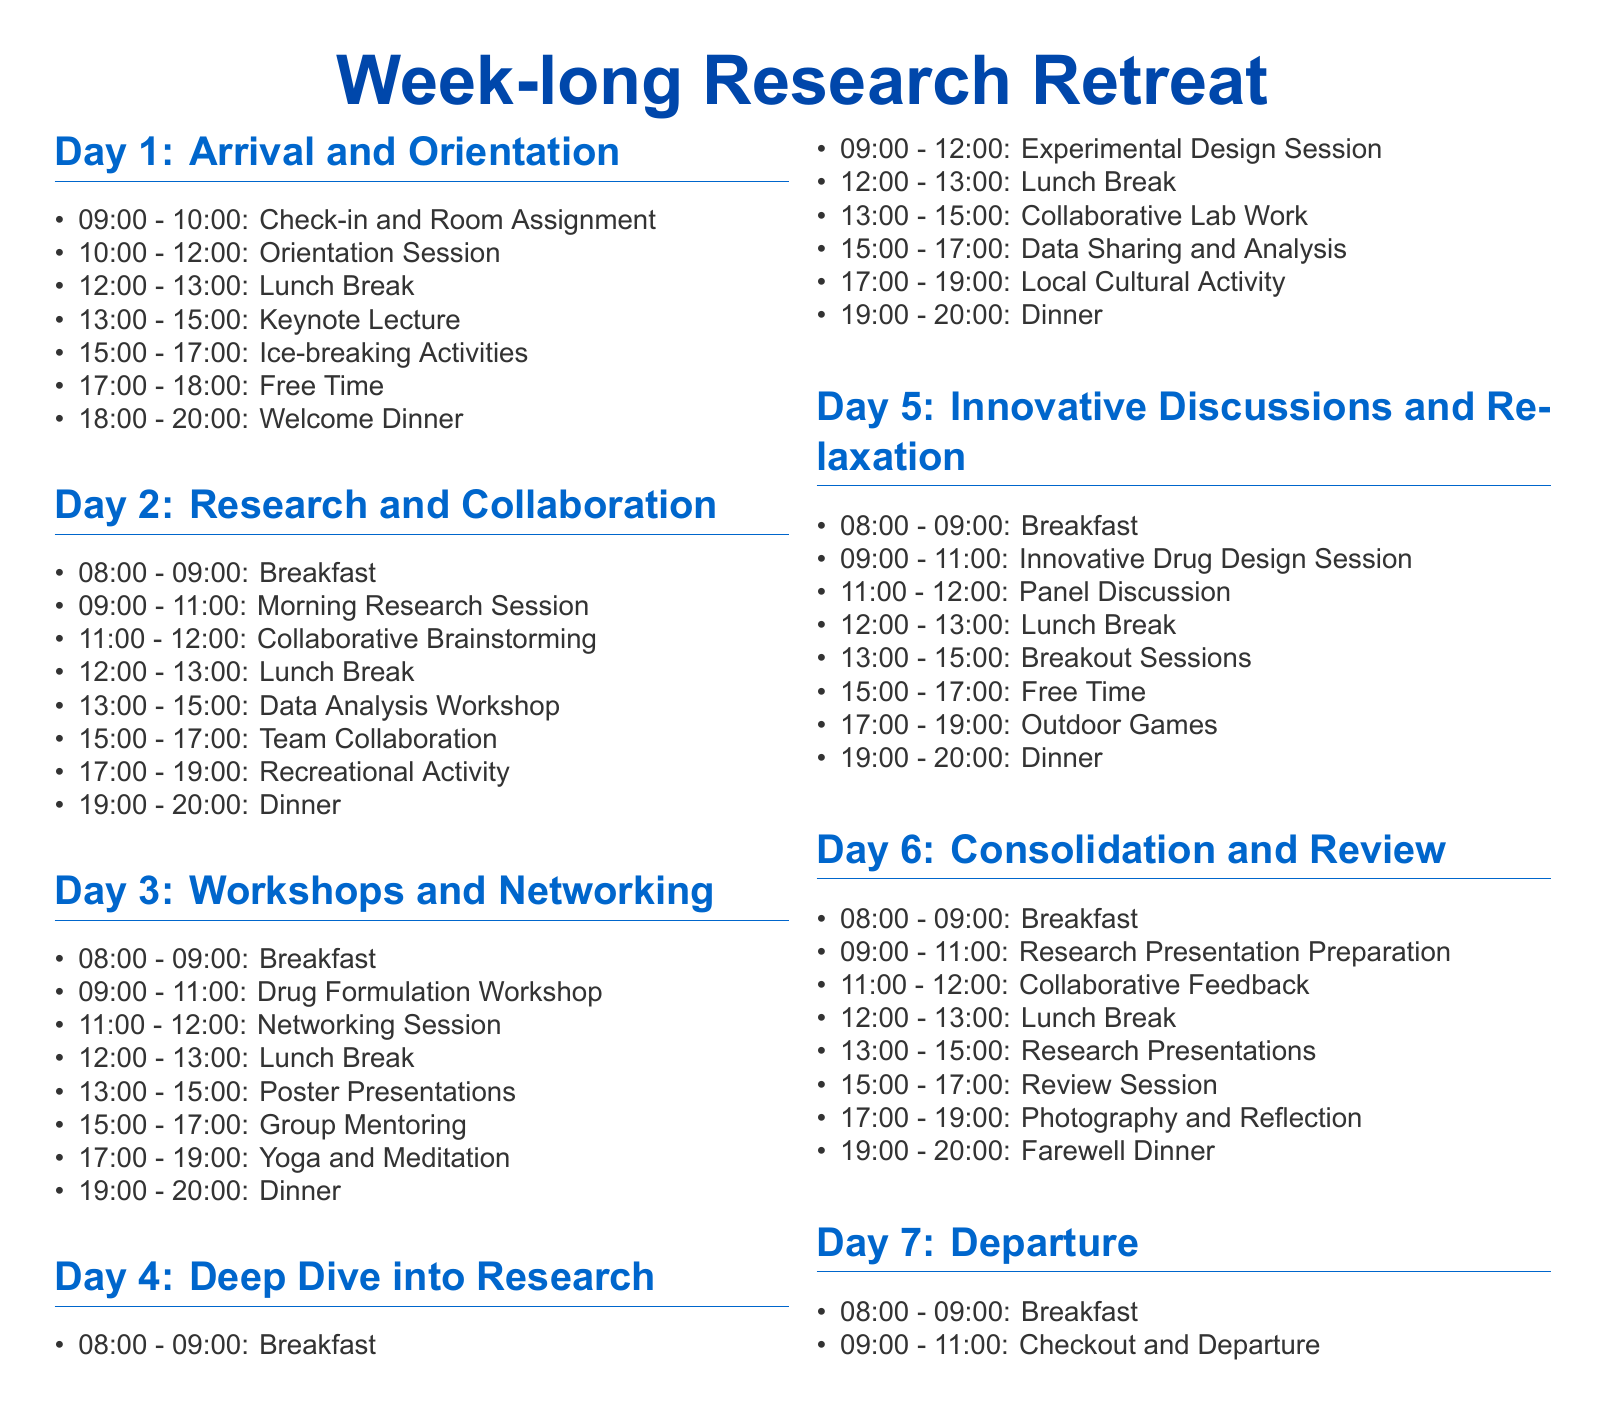what time is breakfast on Day 2? Breakfast is scheduled for 08:00 on Day 2.
Answer: 08:00 how many sessions are scheduled before lunch on Day 3? There are three sessions: Drug Formulation Workshop, Networking Session, and Lunch Break.
Answer: 3 what activity takes place from 17:00 to 19:00 on Day 5? The activity scheduled is Outdoor Games.
Answer: Outdoor Games which day includes a Keynote Lecture? The Keynote Lecture is included on Day 1.
Answer: Day 1 what follows the Research Presentation Preparation on Day 6? Collaborative Feedback follows the Research Presentation Preparation.
Answer: Collaborative Feedback on which day do participants have a Welcome Dinner? The Welcome Dinner takes place on Day 1.
Answer: Day 1 how long is the Orientation Session on Day 1? The Orientation Session lasts for 2 hours.
Answer: 2 hours on which days is there free time scheduled? Free time is scheduled on Day 1 and Day 5.
Answer: Day 1 and Day 5 what type of session is scheduled between 09:00 and 11:00 on Day 4? An Experimental Design Session is scheduled during that time.
Answer: Experimental Design Session 